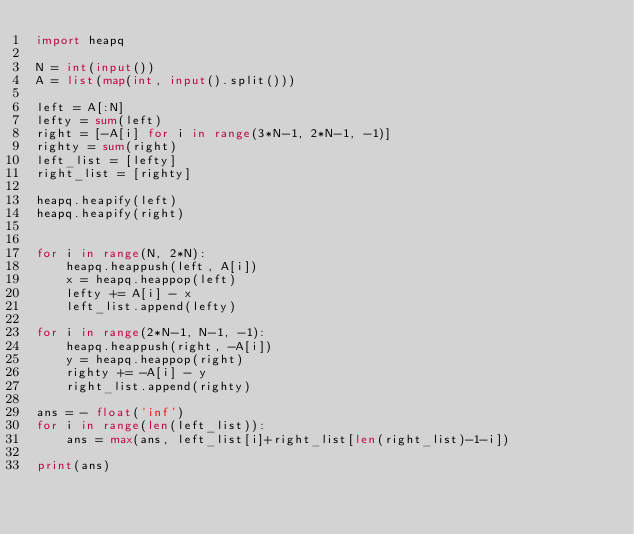<code> <loc_0><loc_0><loc_500><loc_500><_Python_>import heapq

N = int(input())
A = list(map(int, input().split()))

left = A[:N]
lefty = sum(left)
right = [-A[i] for i in range(3*N-1, 2*N-1, -1)]
righty = sum(right)
left_list = [lefty]
right_list = [righty]

heapq.heapify(left)
heapq.heapify(right)


for i in range(N, 2*N):
    heapq.heappush(left, A[i])
    x = heapq.heappop(left)
    lefty += A[i] - x
    left_list.append(lefty)

for i in range(2*N-1, N-1, -1):
    heapq.heappush(right, -A[i])
    y = heapq.heappop(right)
    righty += -A[i] - y
    right_list.append(righty)

ans = - float('inf')
for i in range(len(left_list)):
    ans = max(ans, left_list[i]+right_list[len(right_list)-1-i])

print(ans)
</code> 